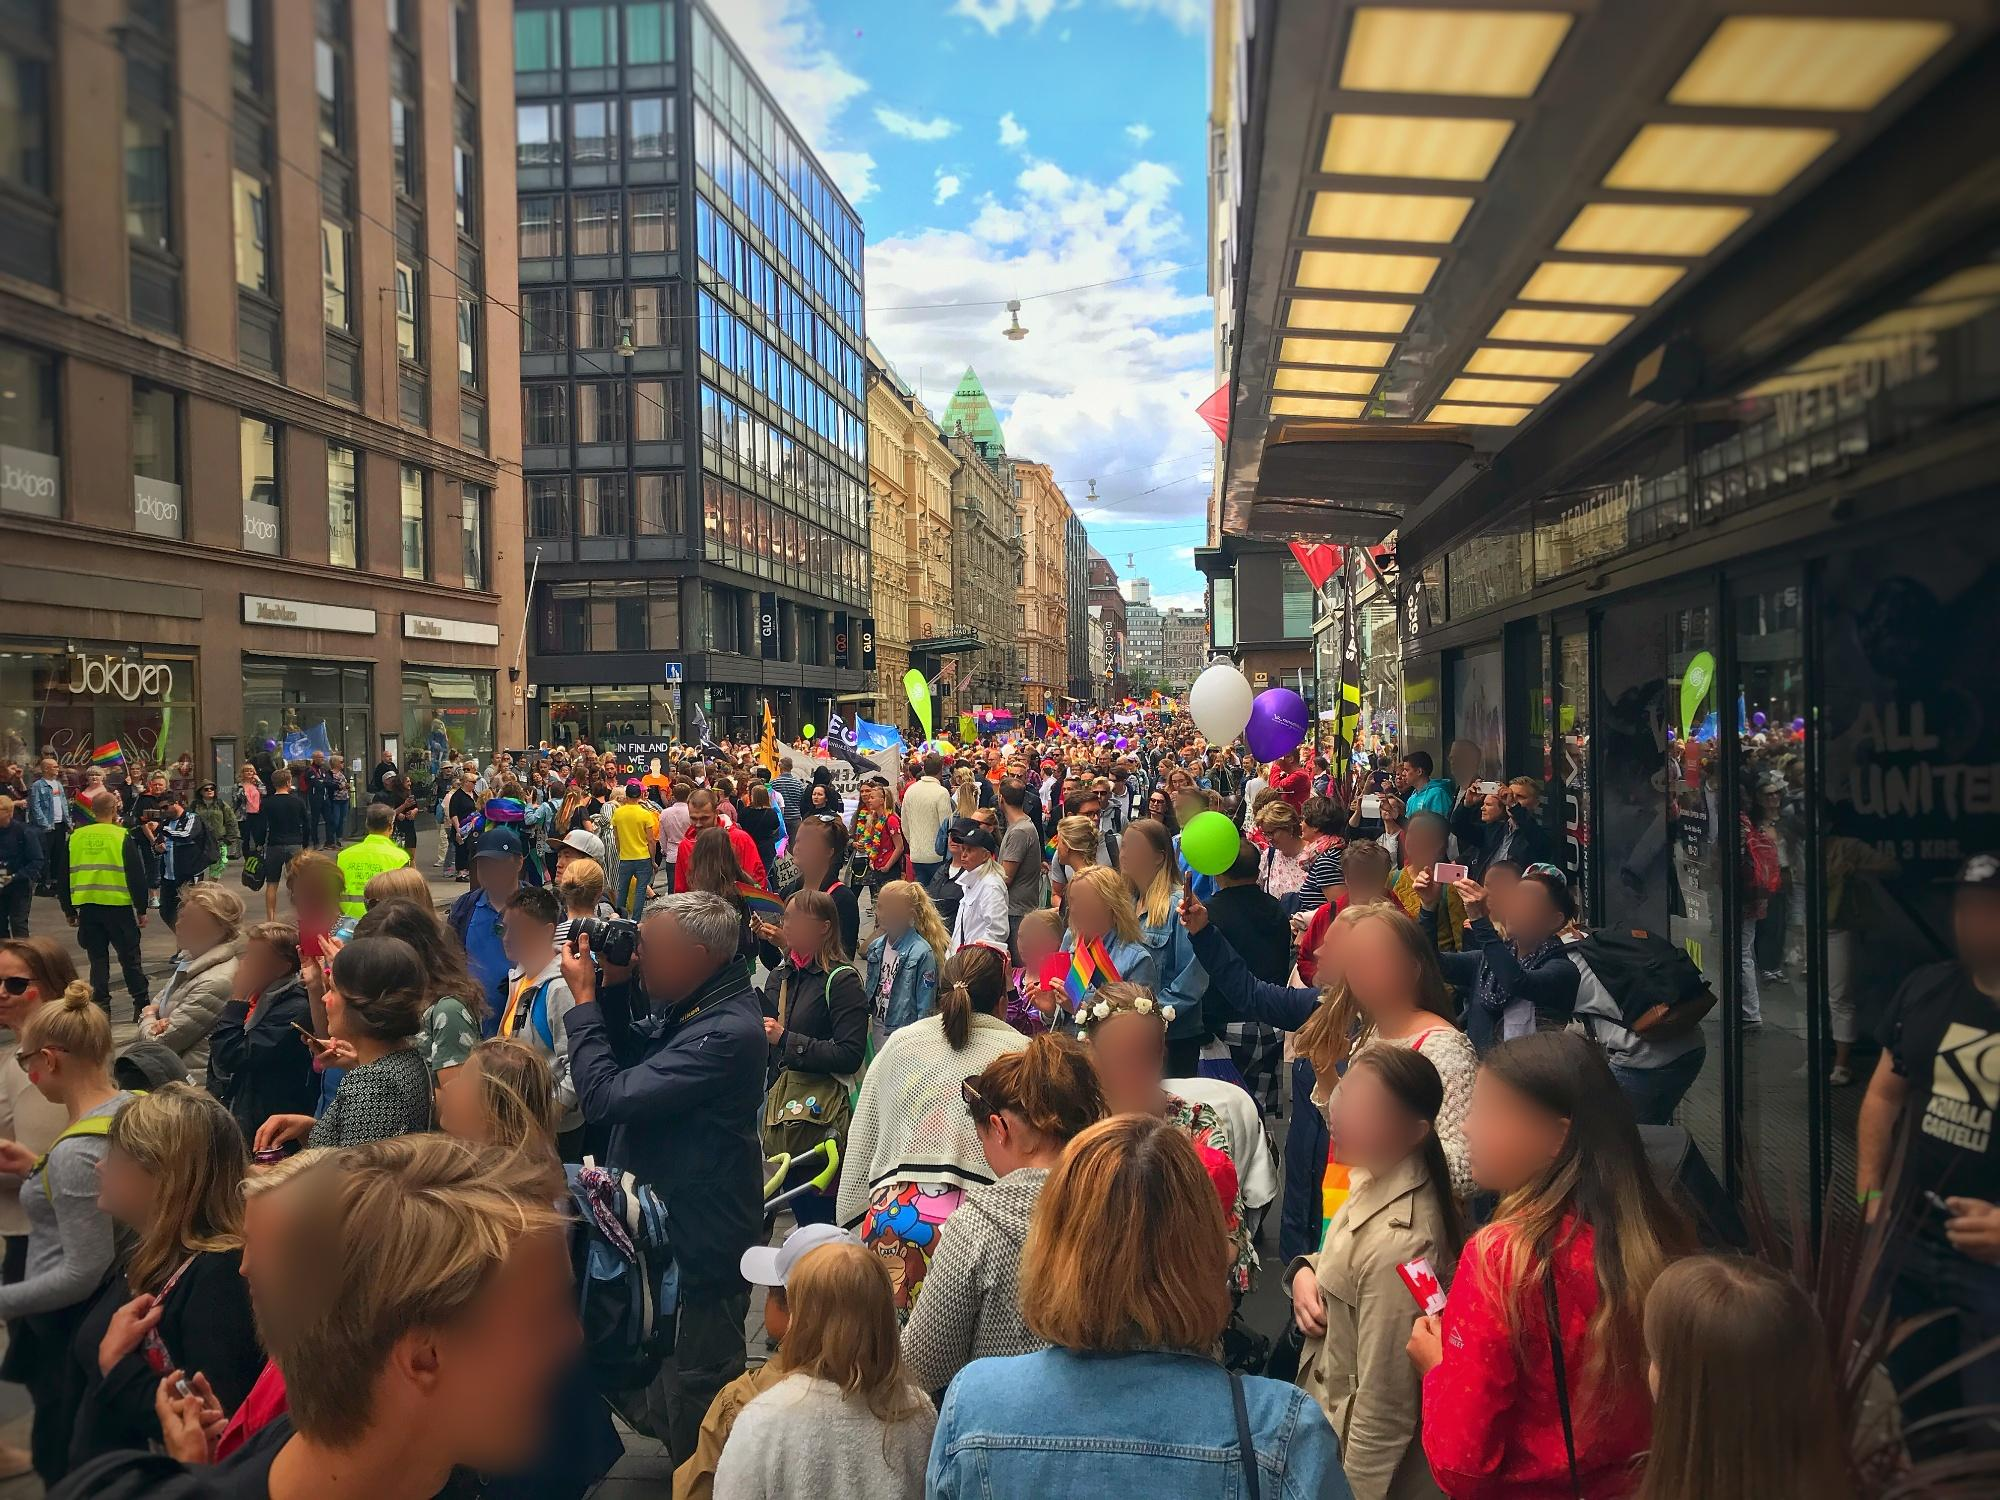Explain the visual content of the image in great detail. The image portrays a lively parade taking place on a bustling Helsinki street. A sea of people fills the landscape, with many holding vibrant, colorful balloons that contribute to the festive atmosphere. The crowd appears engaged and cheerful, with some individuals capturing the moment with cameras and smartphones. Lining the street are modern buildings with large windows that reflect the bright blue sky dotted with a few scattered clouds. The architecture is a mix of sleek modern facades and classic European structures. The image is shot from a perspective that places the viewer on the sidewalk, providing a dynamic view of the exuberant crowd and the parade's procession down the street. Despite the landmark identifier 'sa_13754' appearing in the image metadata, it doesn't shed additional light on the specific location or event, but the prominent architectural styles and the vibrancy point towards a celebration unique to Helsinki's urban charm. 